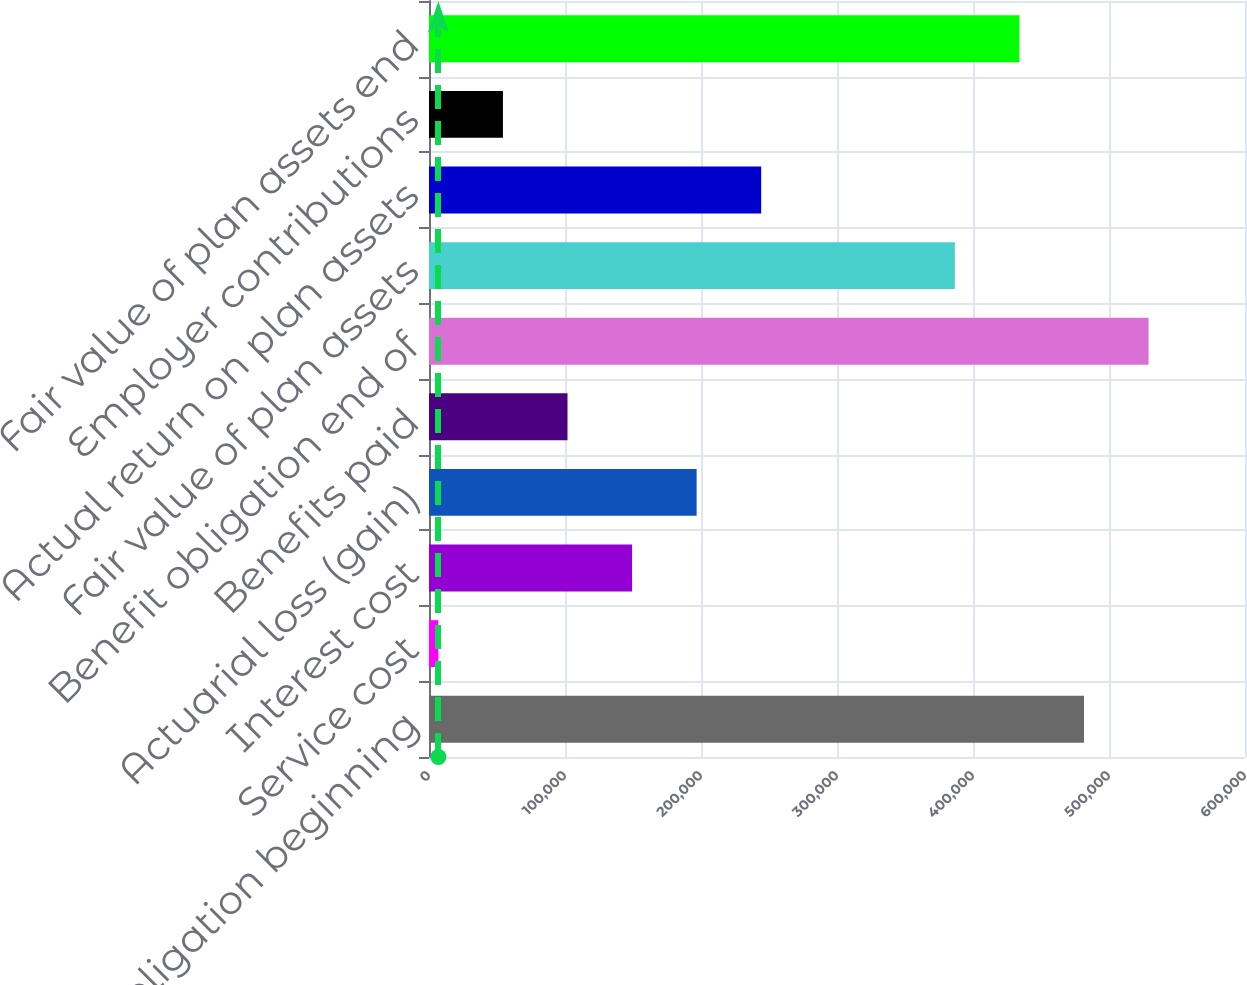Convert chart. <chart><loc_0><loc_0><loc_500><loc_500><bar_chart><fcel>Benefit obligation beginning<fcel>Service cost<fcel>Interest cost<fcel>Actuarial loss (gain)<fcel>Benefits paid<fcel>Benefit obligation end of<fcel>Fair value of plan assets<fcel>Actual return on plan assets<fcel>Employer contributions<fcel>Fair value of plan assets end<nl><fcel>481615<fcel>6896<fcel>149312<fcel>196784<fcel>101840<fcel>529087<fcel>386671<fcel>244256<fcel>54367.9<fcel>434143<nl></chart> 